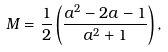Convert formula to latex. <formula><loc_0><loc_0><loc_500><loc_500>M = \frac { 1 } { 2 } \left ( \frac { a ^ { 2 } - 2 a - 1 } { a ^ { 2 } + 1 } \right ) ,</formula> 